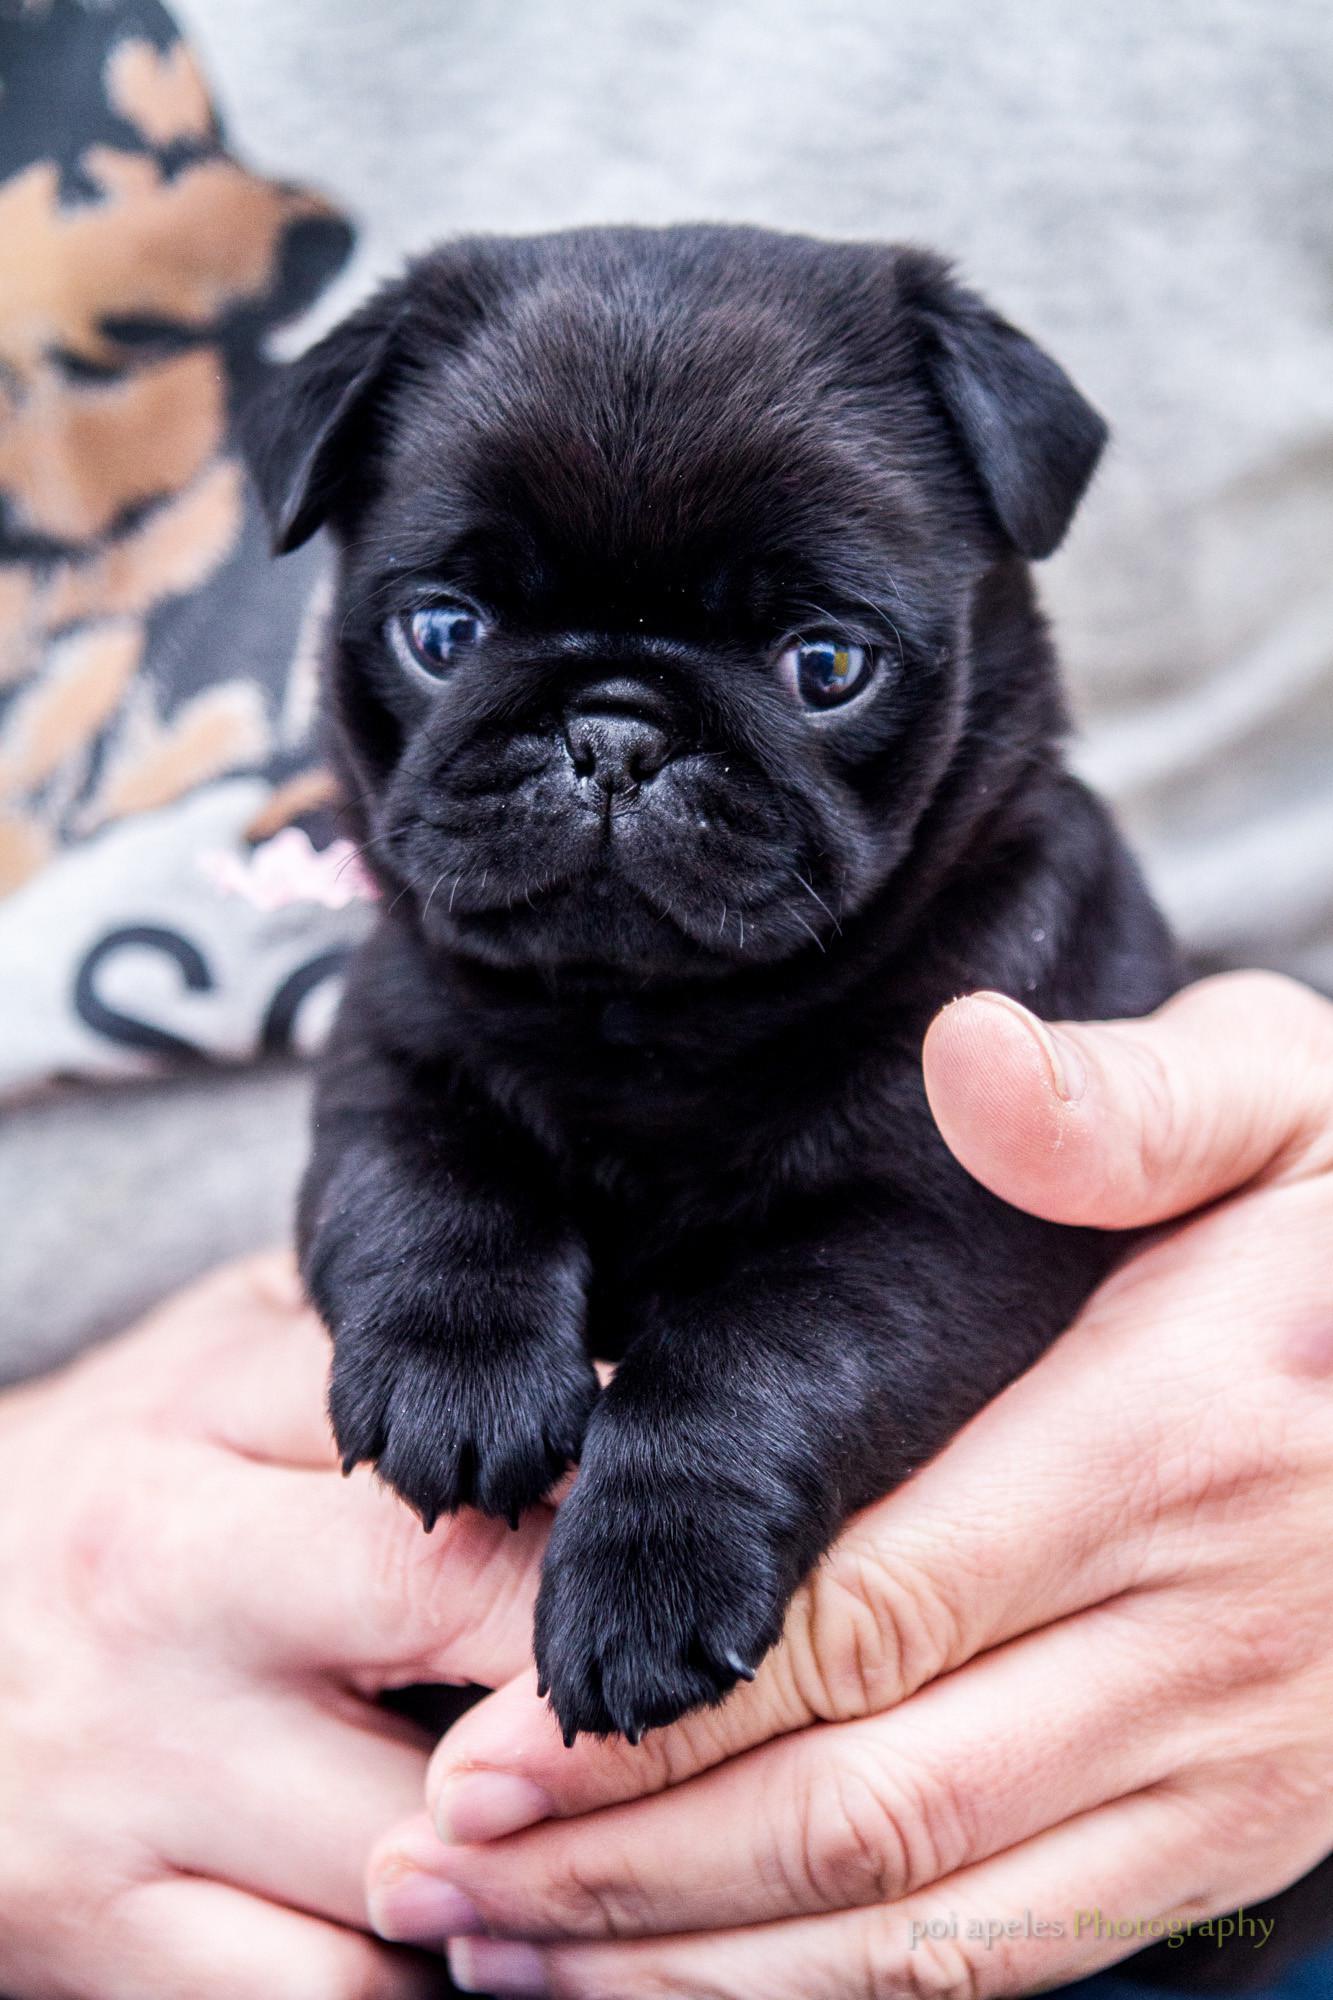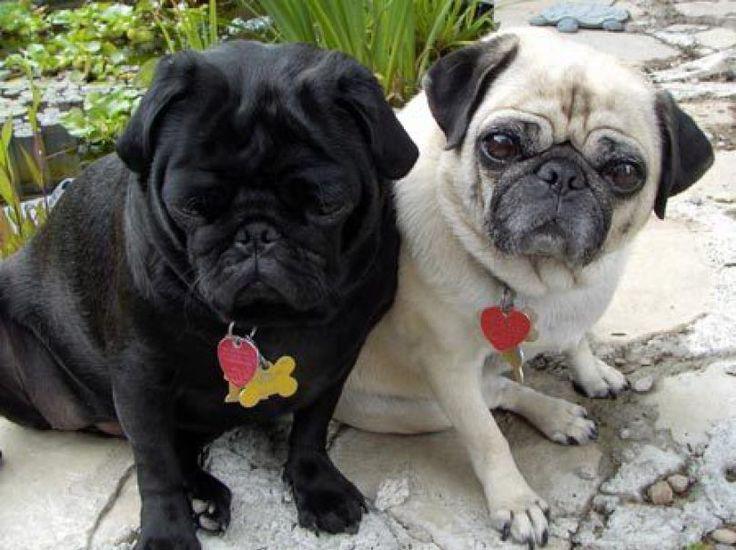The first image is the image on the left, the second image is the image on the right. Examine the images to the left and right. Is the description "The left image features one forward-facing black pug with front paws draped over something, and the right image features a black pug to the left of a beige pug." accurate? Answer yes or no. Yes. The first image is the image on the left, the second image is the image on the right. Analyze the images presented: Is the assertion "The right image contains exactly two dogs." valid? Answer yes or no. Yes. 